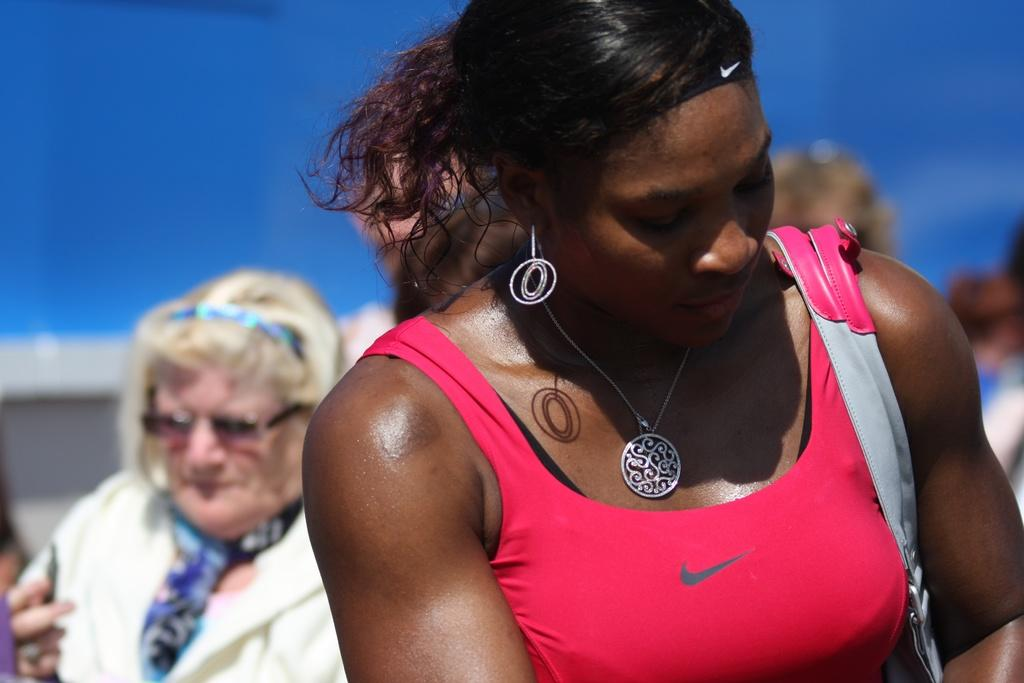Who is the main subject in the image? There is a woman in the image. What is the woman holding or carrying in the image? The woman is carrying a bag. Can you describe the background of the image? There are people visible in the background, and the sky is also visible. How many spiders are crawling on the woman's bag in the image? There are no spiders visible on the woman's bag in the image. What achievement has the woman in the image recently accomplished? There is no information about the woman's achievements in the image. 